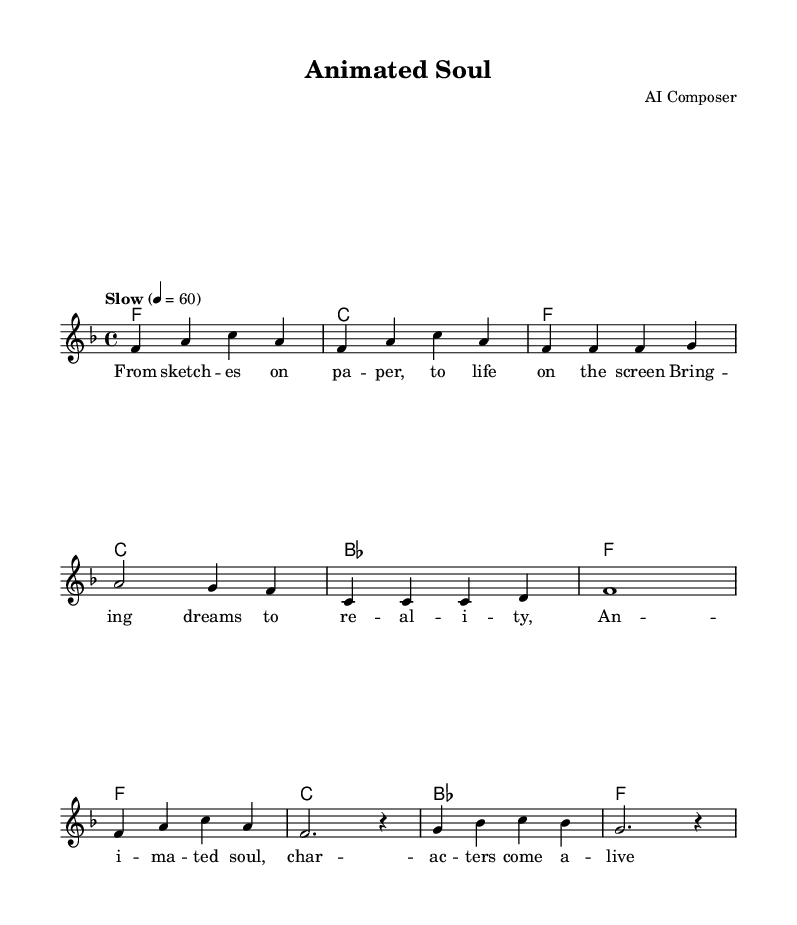What is the key signature of this music? The key signature is F major, which has one flat (B flat). This is indicated at the beginning of the score before the time signature.
Answer: F major What is the time signature of this piece? The time signature is 4/4, which indicates that there are four beats in each measure and the quarter note gets one beat. This is found in the same location as the key signature.
Answer: 4/4 What is the tempo marking of this music? The tempo marking is "Slow" and is indicated with the metronome marking of 60 beats per minute. This can be found written above the music at the beginning of the score.
Answer: Slow How many measures are in the chorus section? The chorus section consists of four measures, which can be counted by looking at the bars used in the chorus lyrics and notes. Each set of music notation between vertical lines represents a measure.
Answer: 4 What type of harmonies are used in the verse? The harmonies in the verse are triadic chords: F, C, B flat, and F again. This is determined by examining the chord symbols above the melody during the verse section.
Answer: Triadic What is the first line of lyrics in the verse? The first line of lyrics in the verse is "From sketch -- es on pa -- per, to life on the screen." This is found under the melody notes where the lyrics are aligned with the notes.
Answer: From sketch -- es on pa -- per, to life on the screen What is the overall theme of the song? The overall theme is about bringing characters to life through animation, as conveyed through the lyrics and the title "Animated Soul." This can be inferred from the lyrics and the creative context of the music.
Answer: Bringing characters to life 